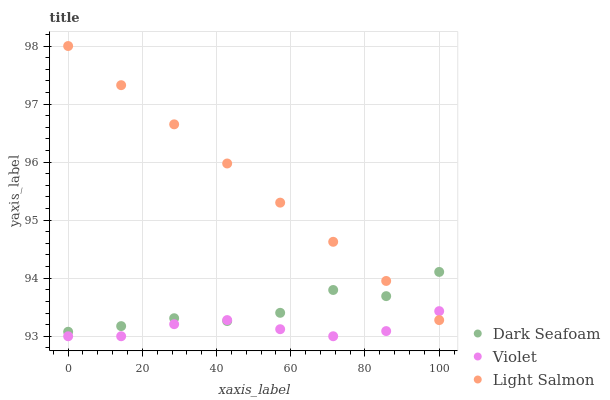Does Violet have the minimum area under the curve?
Answer yes or no. Yes. Does Light Salmon have the maximum area under the curve?
Answer yes or no. Yes. Does Light Salmon have the minimum area under the curve?
Answer yes or no. No. Does Violet have the maximum area under the curve?
Answer yes or no. No. Is Light Salmon the smoothest?
Answer yes or no. Yes. Is Dark Seafoam the roughest?
Answer yes or no. Yes. Is Violet the smoothest?
Answer yes or no. No. Is Violet the roughest?
Answer yes or no. No. Does Violet have the lowest value?
Answer yes or no. Yes. Does Light Salmon have the lowest value?
Answer yes or no. No. Does Light Salmon have the highest value?
Answer yes or no. Yes. Does Violet have the highest value?
Answer yes or no. No. Does Violet intersect Dark Seafoam?
Answer yes or no. Yes. Is Violet less than Dark Seafoam?
Answer yes or no. No. Is Violet greater than Dark Seafoam?
Answer yes or no. No. 